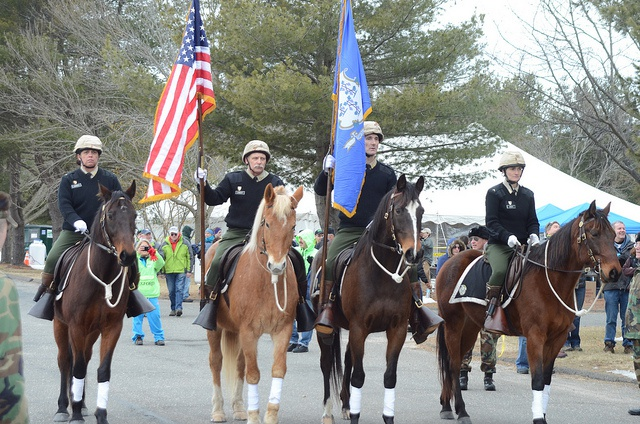Describe the objects in this image and their specific colors. I can see horse in darkgreen, black, maroon, gray, and brown tones, horse in darkgreen, gray, darkgray, tan, and lightgray tones, horse in darkgreen, black, gray, and lightgray tones, horse in darkgreen, black, gray, maroon, and lightgray tones, and people in darkgreen, black, gray, darkgray, and lightgray tones in this image. 